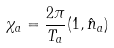Convert formula to latex. <formula><loc_0><loc_0><loc_500><loc_500>\chi _ { a } = \frac { 2 \pi } { T _ { a } } ( 1 , \hat { n } _ { a } )</formula> 